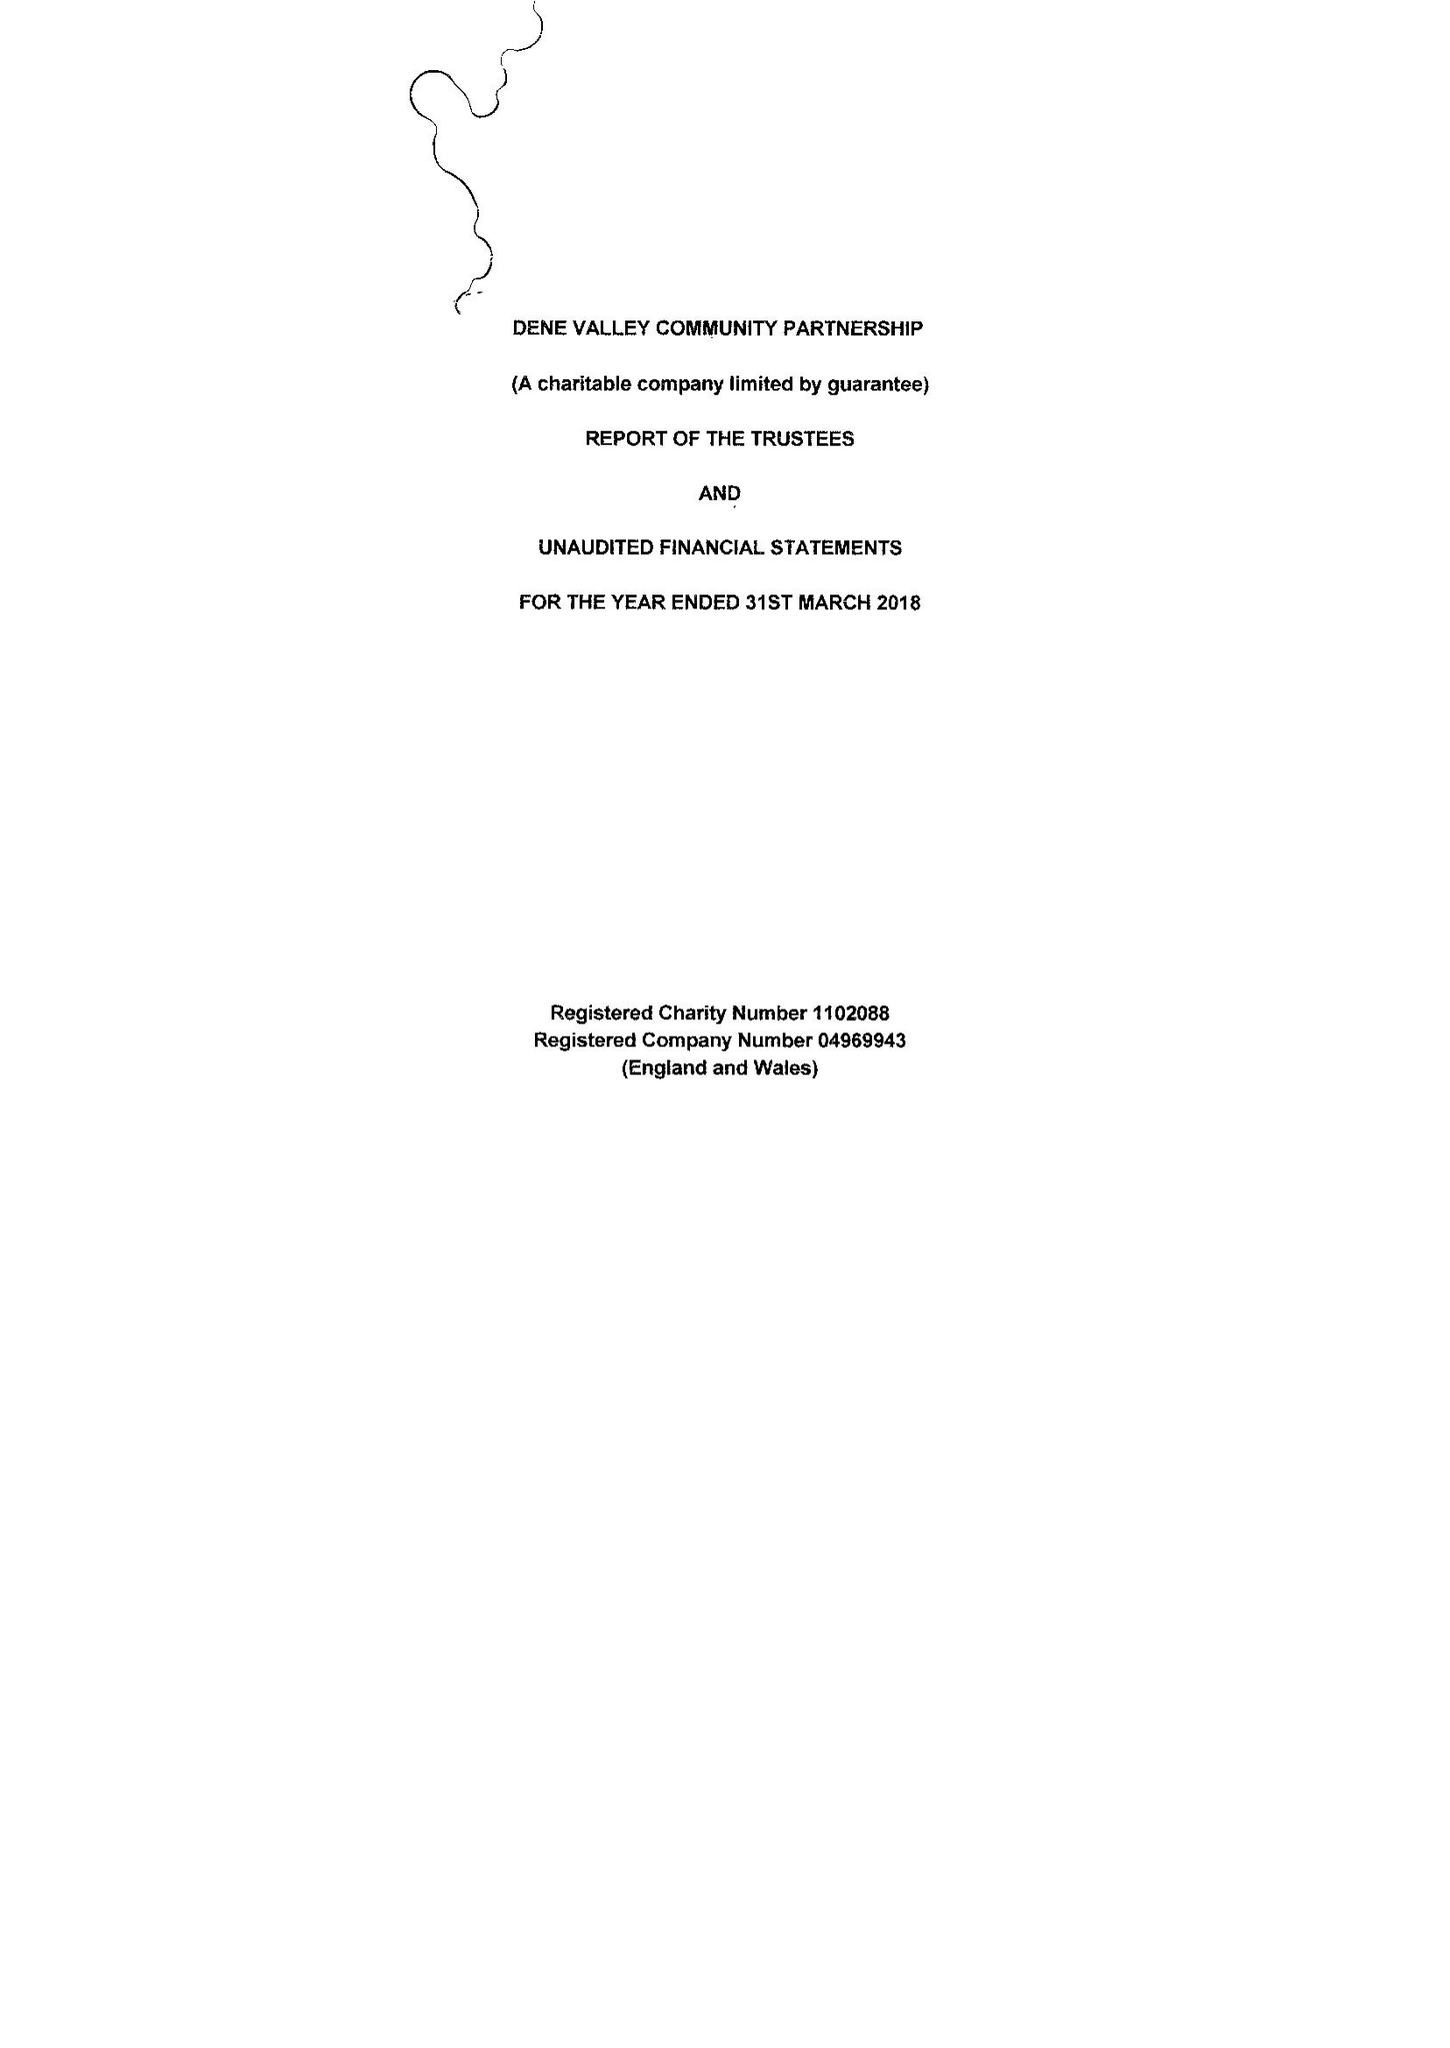What is the value for the report_date?
Answer the question using a single word or phrase. 2018-03-31 